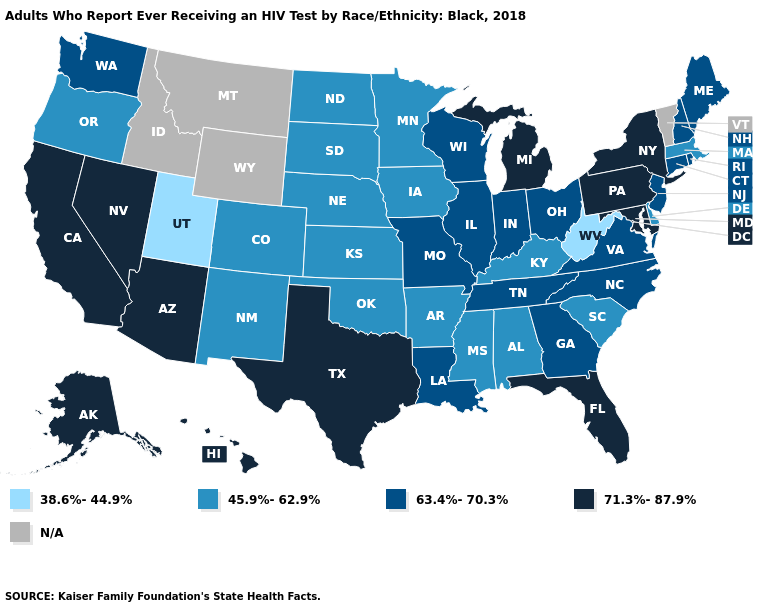What is the lowest value in states that border Arizona?
Quick response, please. 38.6%-44.9%. Does South Carolina have the highest value in the USA?
Write a very short answer. No. Name the states that have a value in the range 38.6%-44.9%?
Short answer required. Utah, West Virginia. What is the highest value in states that border Wyoming?
Concise answer only. 45.9%-62.9%. What is the value of Illinois?
Write a very short answer. 63.4%-70.3%. Name the states that have a value in the range 63.4%-70.3%?
Quick response, please. Connecticut, Georgia, Illinois, Indiana, Louisiana, Maine, Missouri, New Hampshire, New Jersey, North Carolina, Ohio, Rhode Island, Tennessee, Virginia, Washington, Wisconsin. Which states have the highest value in the USA?
Short answer required. Alaska, Arizona, California, Florida, Hawaii, Maryland, Michigan, Nevada, New York, Pennsylvania, Texas. What is the highest value in the Northeast ?
Give a very brief answer. 71.3%-87.9%. Which states have the lowest value in the Northeast?
Quick response, please. Massachusetts. Among the states that border Oregon , which have the highest value?
Write a very short answer. California, Nevada. What is the value of Maine?
Write a very short answer. 63.4%-70.3%. What is the value of Kansas?
Be succinct. 45.9%-62.9%. Name the states that have a value in the range 45.9%-62.9%?
Answer briefly. Alabama, Arkansas, Colorado, Delaware, Iowa, Kansas, Kentucky, Massachusetts, Minnesota, Mississippi, Nebraska, New Mexico, North Dakota, Oklahoma, Oregon, South Carolina, South Dakota. 